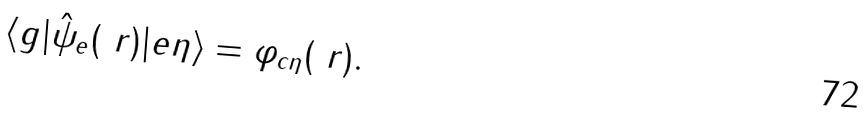Convert formula to latex. <formula><loc_0><loc_0><loc_500><loc_500>\langle g | \hat { \psi } _ { e } ( \ r ) | e \eta \rangle = \varphi _ { c \eta } ( \ r ) .</formula> 